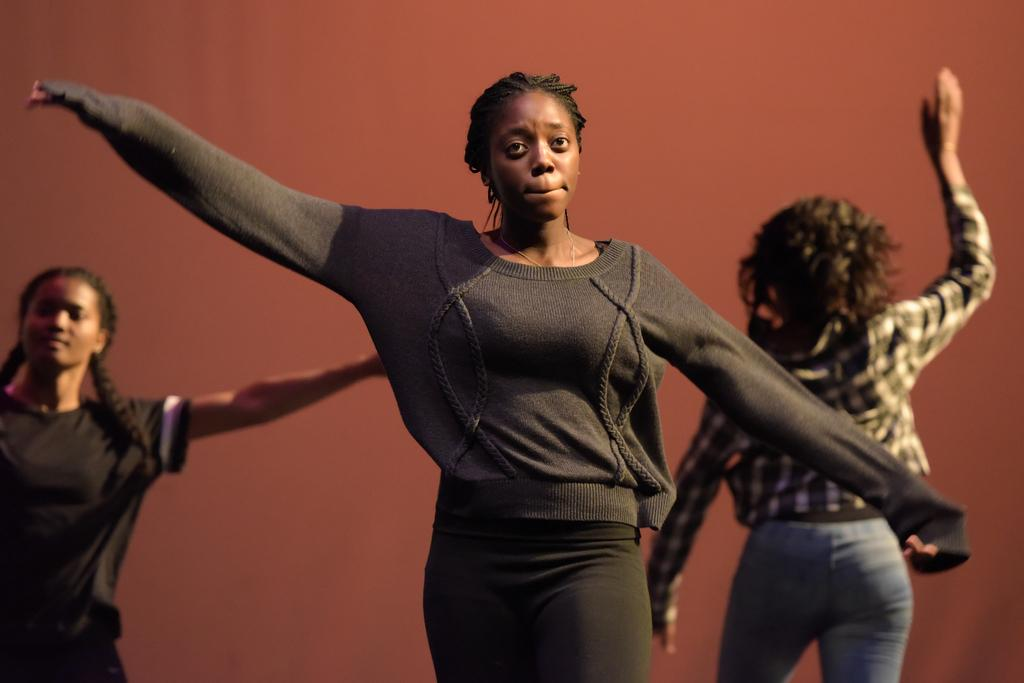How many people are in the image? There are three women in the image. What are the women doing in the image? The women are dancing. What can be seen in the background of the image? There is a wall in the background of the image. What type of bean is being used as a prop by one of the women in the image? There is no bean present in the image, and none of the women are using any props. 